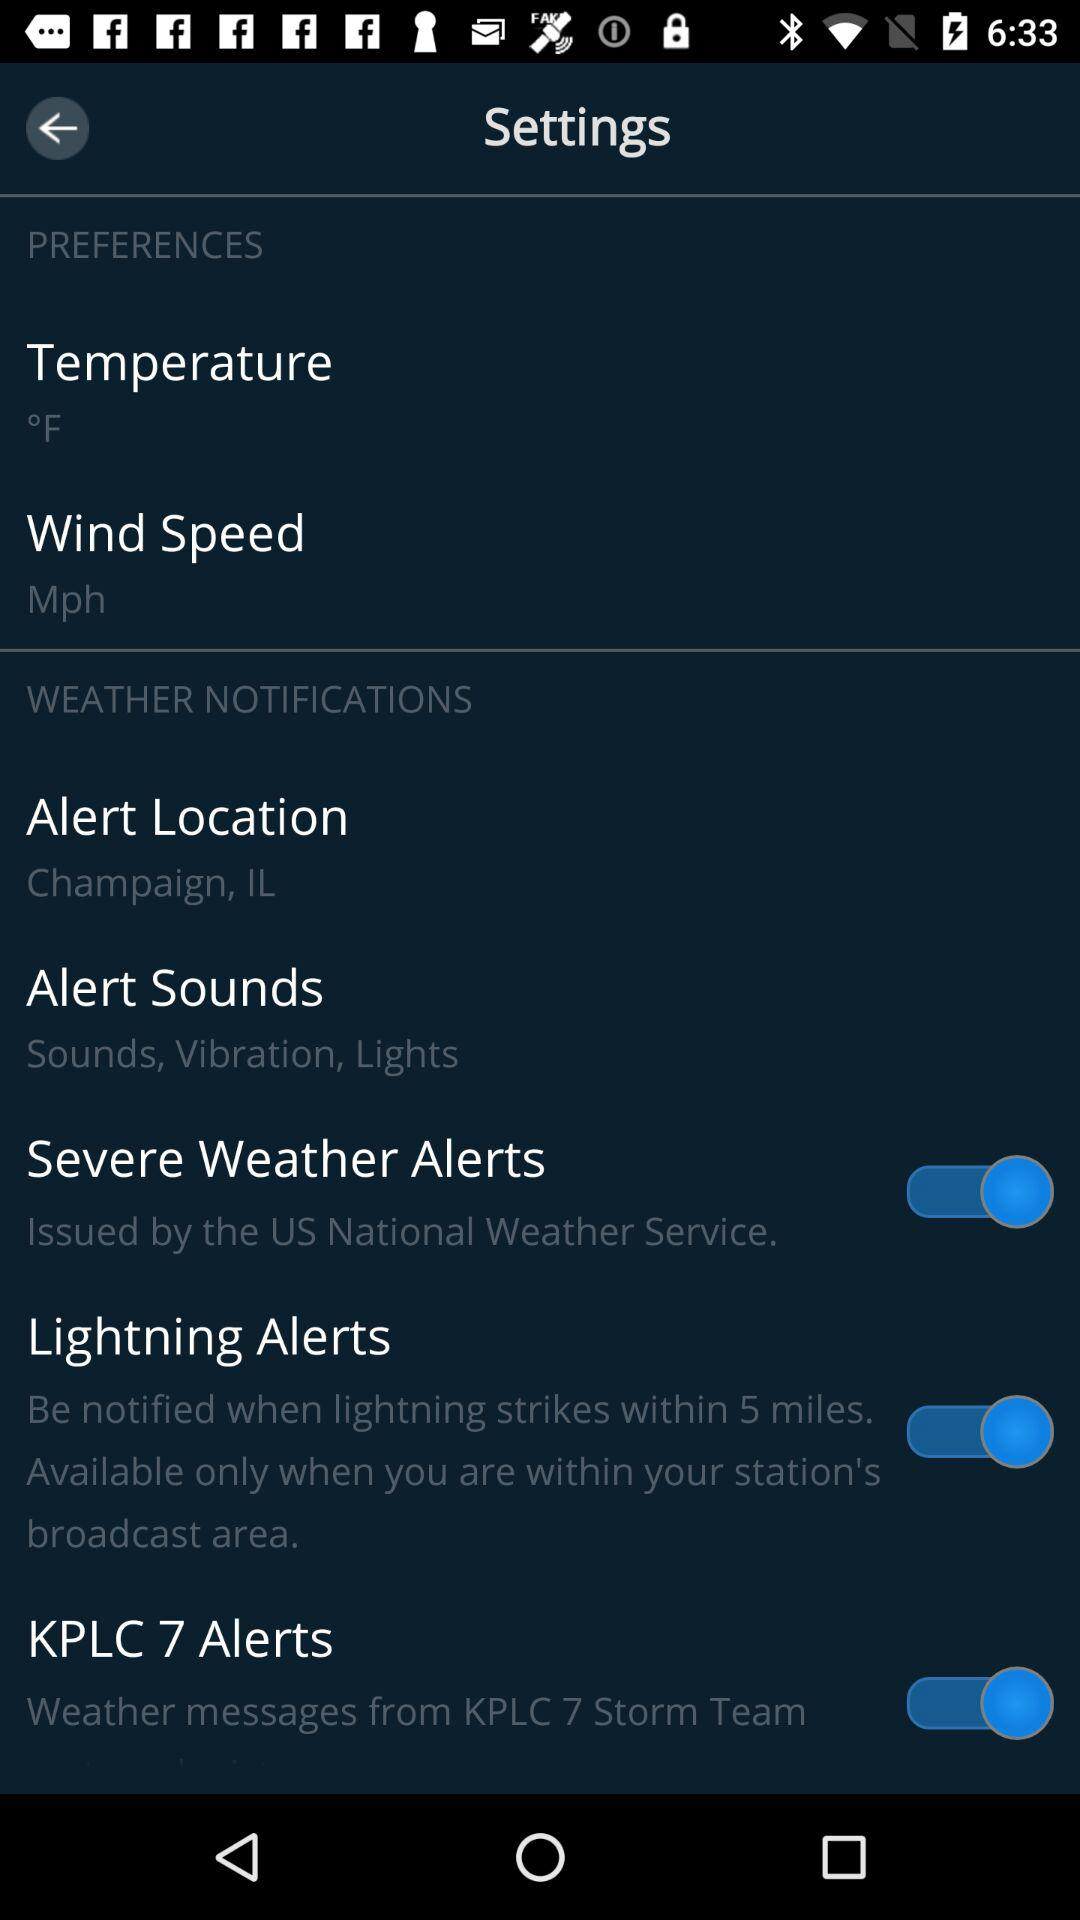Who has issued the "Severe Weather Alerts"? The "Severe Weather Alert" has been issued by the US National Weather Service. 